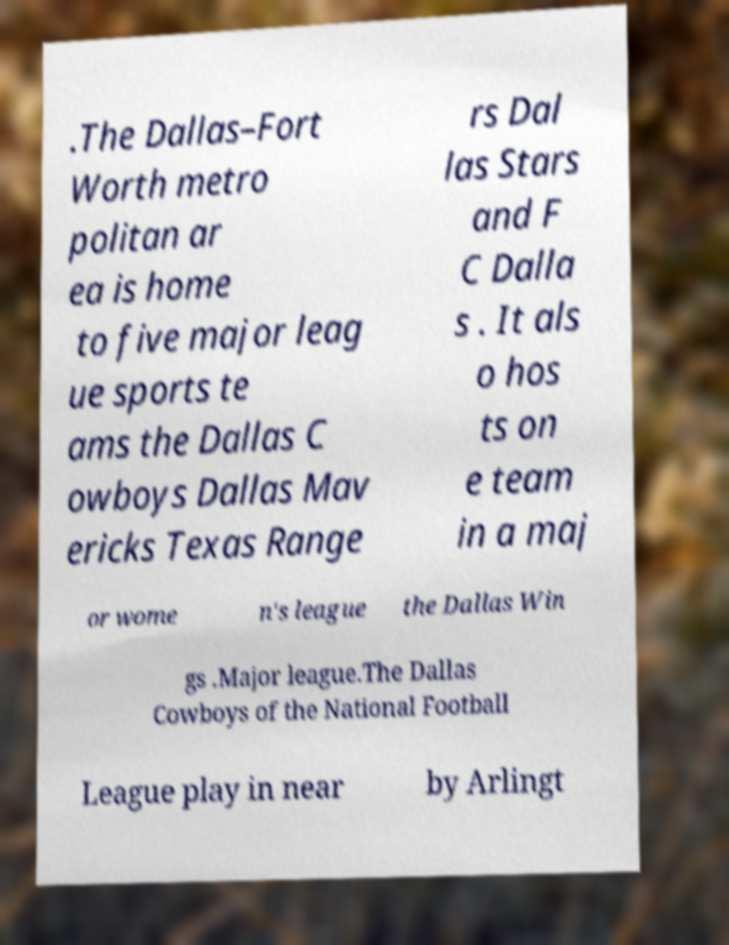I need the written content from this picture converted into text. Can you do that? .The Dallas–Fort Worth metro politan ar ea is home to five major leag ue sports te ams the Dallas C owboys Dallas Mav ericks Texas Range rs Dal las Stars and F C Dalla s . It als o hos ts on e team in a maj or wome n's league the Dallas Win gs .Major league.The Dallas Cowboys of the National Football League play in near by Arlingt 